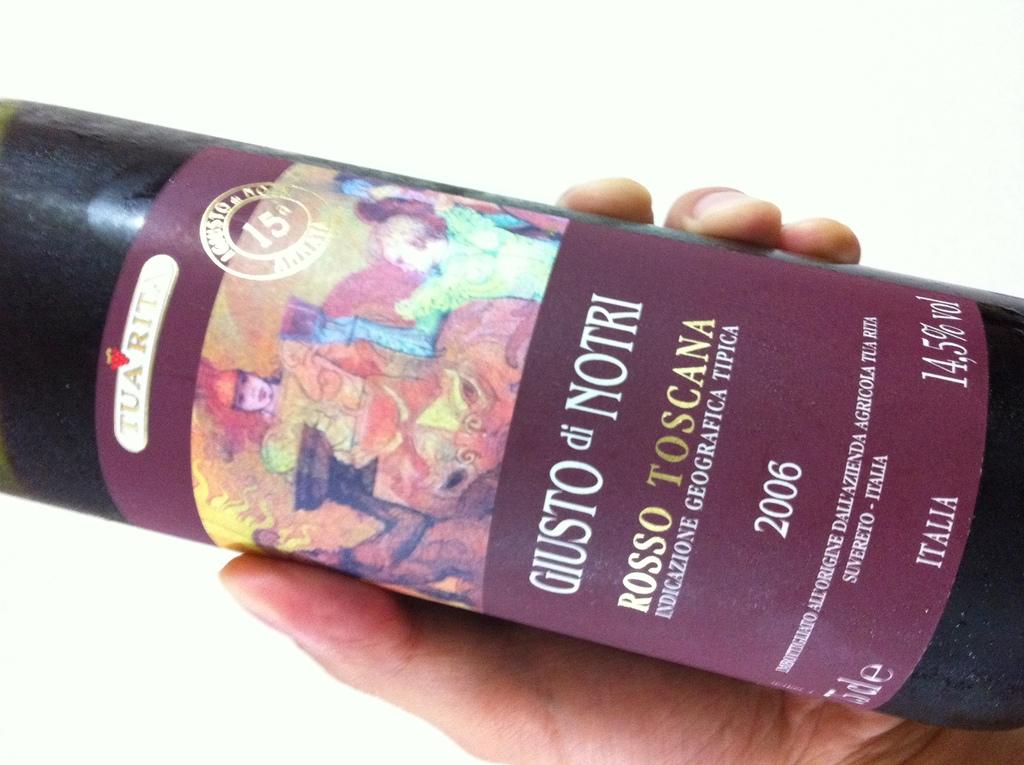What is the alcohol volume?
Provide a short and direct response. 14.5%. 